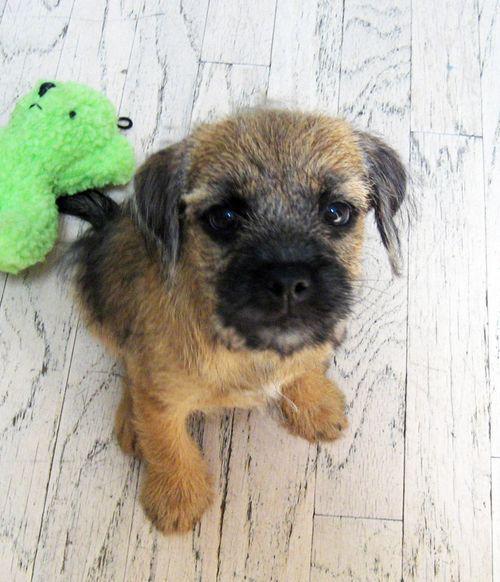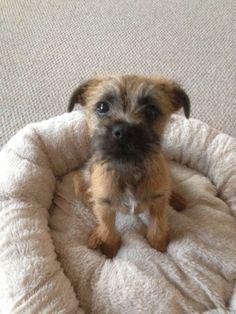The first image is the image on the left, the second image is the image on the right. Given the left and right images, does the statement "The dog in the image on the left is wearing a red collar." hold true? Answer yes or no. No. The first image is the image on the left, the second image is the image on the right. Evaluate the accuracy of this statement regarding the images: "The dog on the left wears a red collar, and the dog on the right looks forward with a tilted head.". Is it true? Answer yes or no. No. 